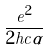Convert formula to latex. <formula><loc_0><loc_0><loc_500><loc_500>\frac { e ^ { 2 } } { 2 h c \alpha }</formula> 